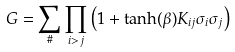Convert formula to latex. <formula><loc_0><loc_0><loc_500><loc_500>G = \sum _ { \# } \prod _ { i > j } \left ( 1 + \tanh ( \beta ) K _ { i j } \sigma _ { i } \sigma _ { j } \right )</formula> 